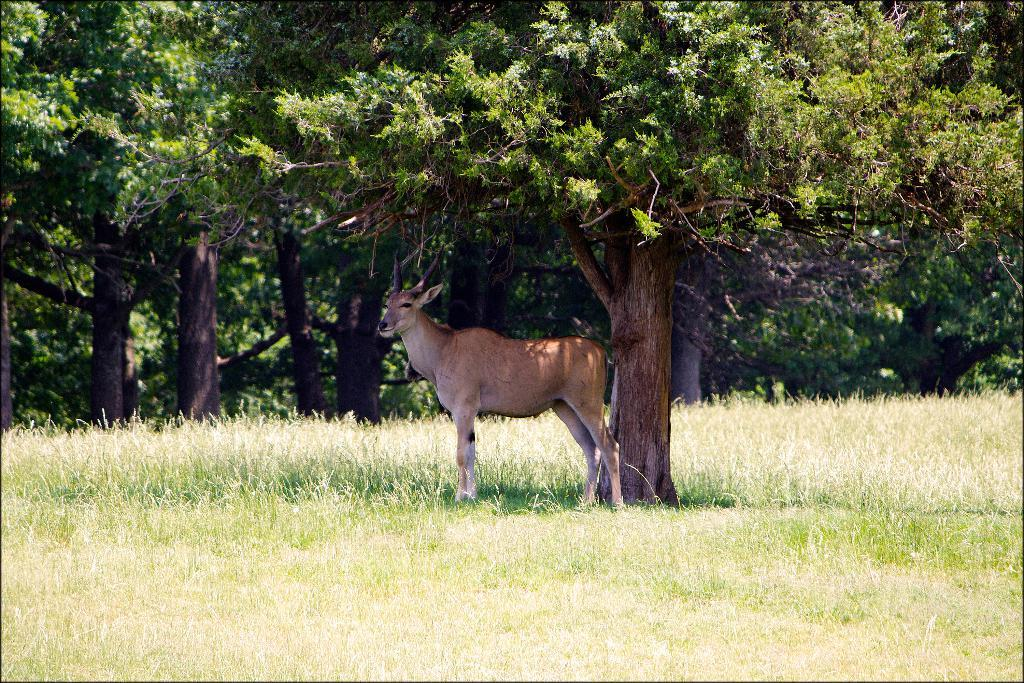What type of animal is in the picture? The type of animal cannot be determined from the provided facts. What can be seen in the background of the picture? There are trees visible in the picture. What is on the ground in the picture? There is grass on the ground in the picture. What color is the collar on the animal in the picture? There is no collar present on the animal in the picture, as the type of animal cannot be determined from the provided facts. 